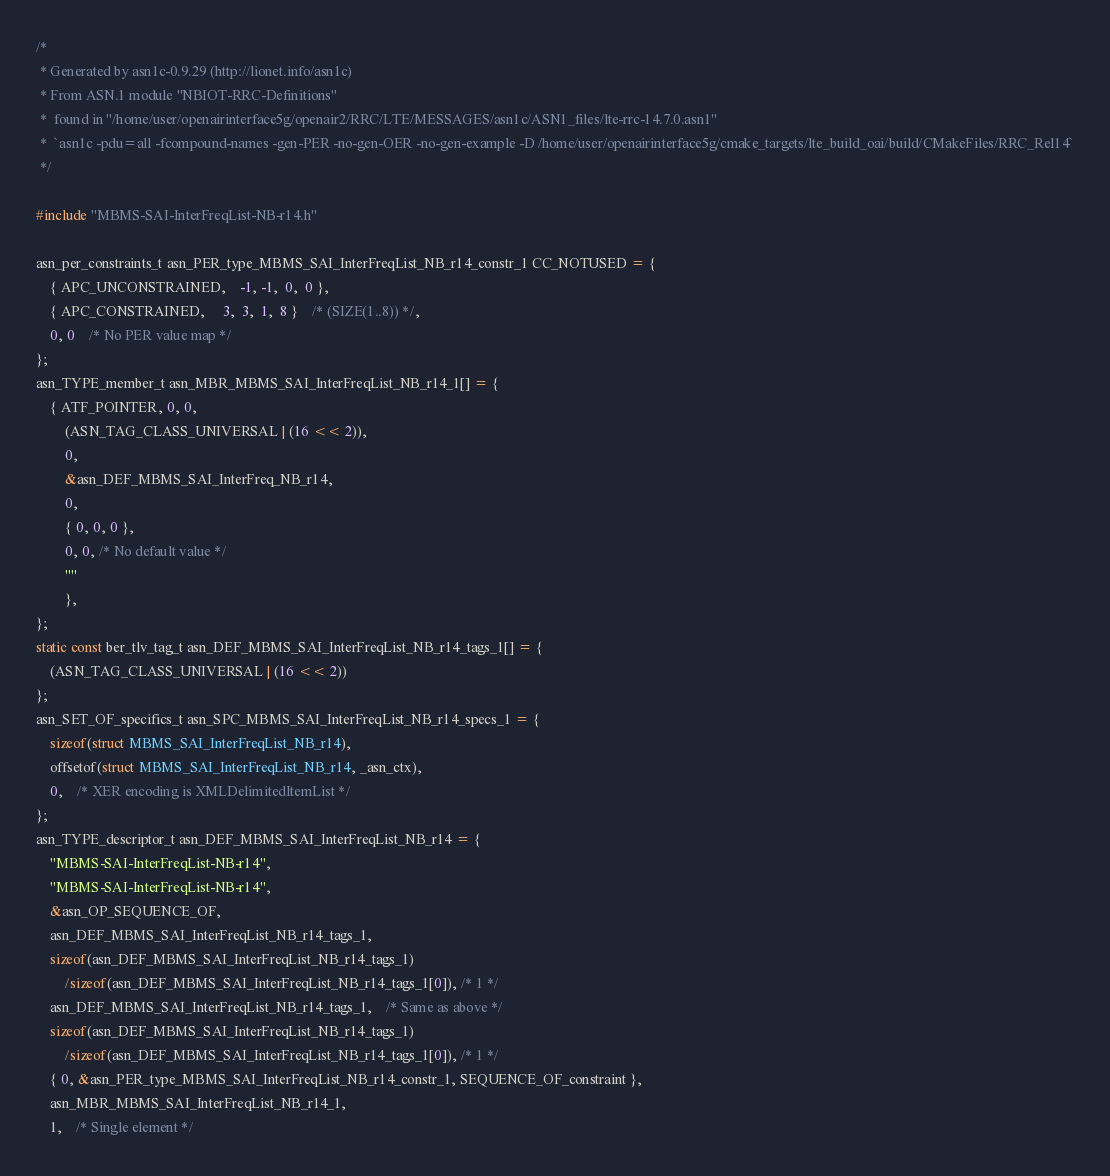Convert code to text. <code><loc_0><loc_0><loc_500><loc_500><_C_>/*
 * Generated by asn1c-0.9.29 (http://lionet.info/asn1c)
 * From ASN.1 module "NBIOT-RRC-Definitions"
 * 	found in "/home/user/openairinterface5g/openair2/RRC/LTE/MESSAGES/asn1c/ASN1_files/lte-rrc-14.7.0.asn1"
 * 	`asn1c -pdu=all -fcompound-names -gen-PER -no-gen-OER -no-gen-example -D /home/user/openairinterface5g/cmake_targets/lte_build_oai/build/CMakeFiles/RRC_Rel14`
 */

#include "MBMS-SAI-InterFreqList-NB-r14.h"

asn_per_constraints_t asn_PER_type_MBMS_SAI_InterFreqList_NB_r14_constr_1 CC_NOTUSED = {
	{ APC_UNCONSTRAINED,	-1, -1,  0,  0 },
	{ APC_CONSTRAINED,	 3,  3,  1,  8 }	/* (SIZE(1..8)) */,
	0, 0	/* No PER value map */
};
asn_TYPE_member_t asn_MBR_MBMS_SAI_InterFreqList_NB_r14_1[] = {
	{ ATF_POINTER, 0, 0,
		(ASN_TAG_CLASS_UNIVERSAL | (16 << 2)),
		0,
		&asn_DEF_MBMS_SAI_InterFreq_NB_r14,
		0,
		{ 0, 0, 0 },
		0, 0, /* No default value */
		""
		},
};
static const ber_tlv_tag_t asn_DEF_MBMS_SAI_InterFreqList_NB_r14_tags_1[] = {
	(ASN_TAG_CLASS_UNIVERSAL | (16 << 2))
};
asn_SET_OF_specifics_t asn_SPC_MBMS_SAI_InterFreqList_NB_r14_specs_1 = {
	sizeof(struct MBMS_SAI_InterFreqList_NB_r14),
	offsetof(struct MBMS_SAI_InterFreqList_NB_r14, _asn_ctx),
	0,	/* XER encoding is XMLDelimitedItemList */
};
asn_TYPE_descriptor_t asn_DEF_MBMS_SAI_InterFreqList_NB_r14 = {
	"MBMS-SAI-InterFreqList-NB-r14",
	"MBMS-SAI-InterFreqList-NB-r14",
	&asn_OP_SEQUENCE_OF,
	asn_DEF_MBMS_SAI_InterFreqList_NB_r14_tags_1,
	sizeof(asn_DEF_MBMS_SAI_InterFreqList_NB_r14_tags_1)
		/sizeof(asn_DEF_MBMS_SAI_InterFreqList_NB_r14_tags_1[0]), /* 1 */
	asn_DEF_MBMS_SAI_InterFreqList_NB_r14_tags_1,	/* Same as above */
	sizeof(asn_DEF_MBMS_SAI_InterFreqList_NB_r14_tags_1)
		/sizeof(asn_DEF_MBMS_SAI_InterFreqList_NB_r14_tags_1[0]), /* 1 */
	{ 0, &asn_PER_type_MBMS_SAI_InterFreqList_NB_r14_constr_1, SEQUENCE_OF_constraint },
	asn_MBR_MBMS_SAI_InterFreqList_NB_r14_1,
	1,	/* Single element */</code> 